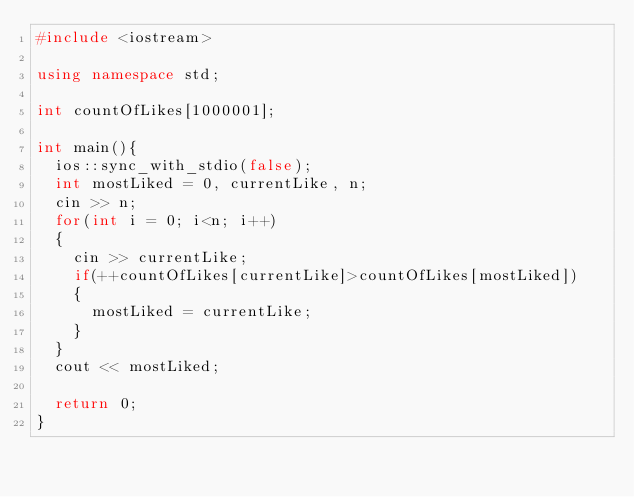Convert code to text. <code><loc_0><loc_0><loc_500><loc_500><_C++_>#include <iostream>

using namespace std;

int countOfLikes[1000001];

int main(){
	ios::sync_with_stdio(false);
	int mostLiked = 0, currentLike, n;
	cin >> n;
	for(int i = 0; i<n; i++)
	{
		cin >> currentLike;
		if(++countOfLikes[currentLike]>countOfLikes[mostLiked])
		{
			mostLiked = currentLike;
		}
	}
	cout << mostLiked;
	
	return 0;
}</code> 